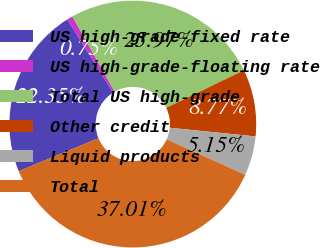Convert chart to OTSL. <chart><loc_0><loc_0><loc_500><loc_500><pie_chart><fcel>US high-grade-fixed rate<fcel>US high-grade-floating rate<fcel>Total US high-grade<fcel>Other credit<fcel>Liquid products<fcel>Total<nl><fcel>22.35%<fcel>0.75%<fcel>25.97%<fcel>8.77%<fcel>5.15%<fcel>37.01%<nl></chart> 